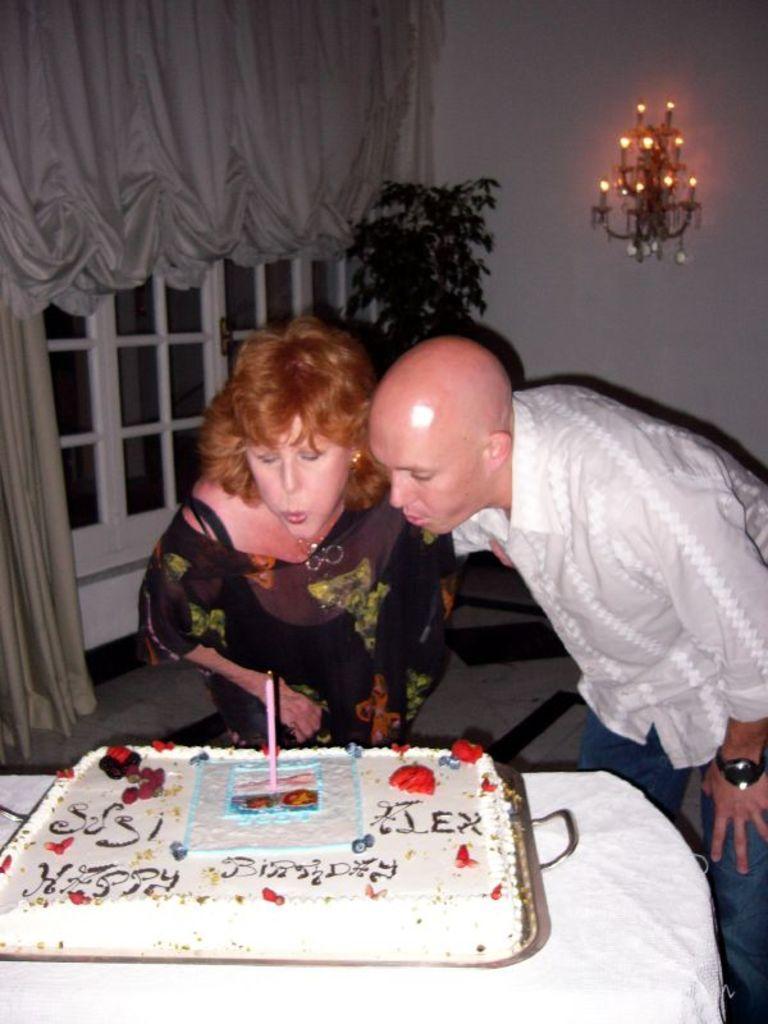Please provide a concise description of this image. On the background of the picture we can see curtains, door , plant and a decorative lamp. Here we can see two persons a man and a woman bending and blowing a candle which is over the cake. This is a table. 